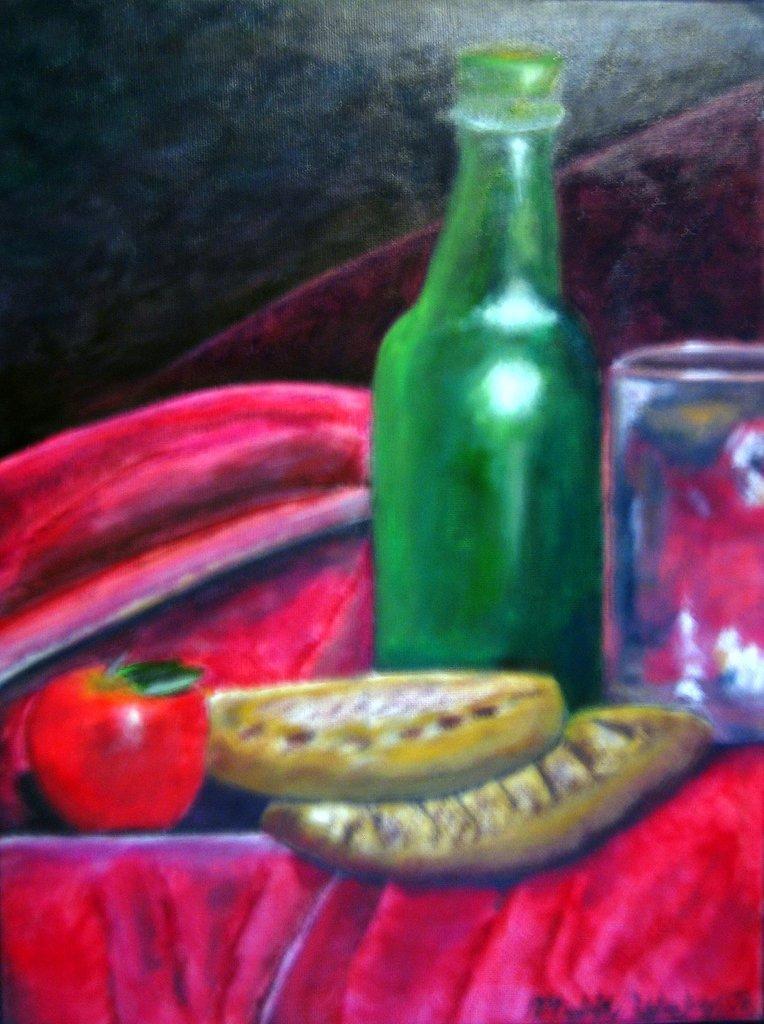How would you summarize this image in a sentence or two? In this picture we can see painting of glass, bottle, fruit and objects. In the background of the image it is blurry. 